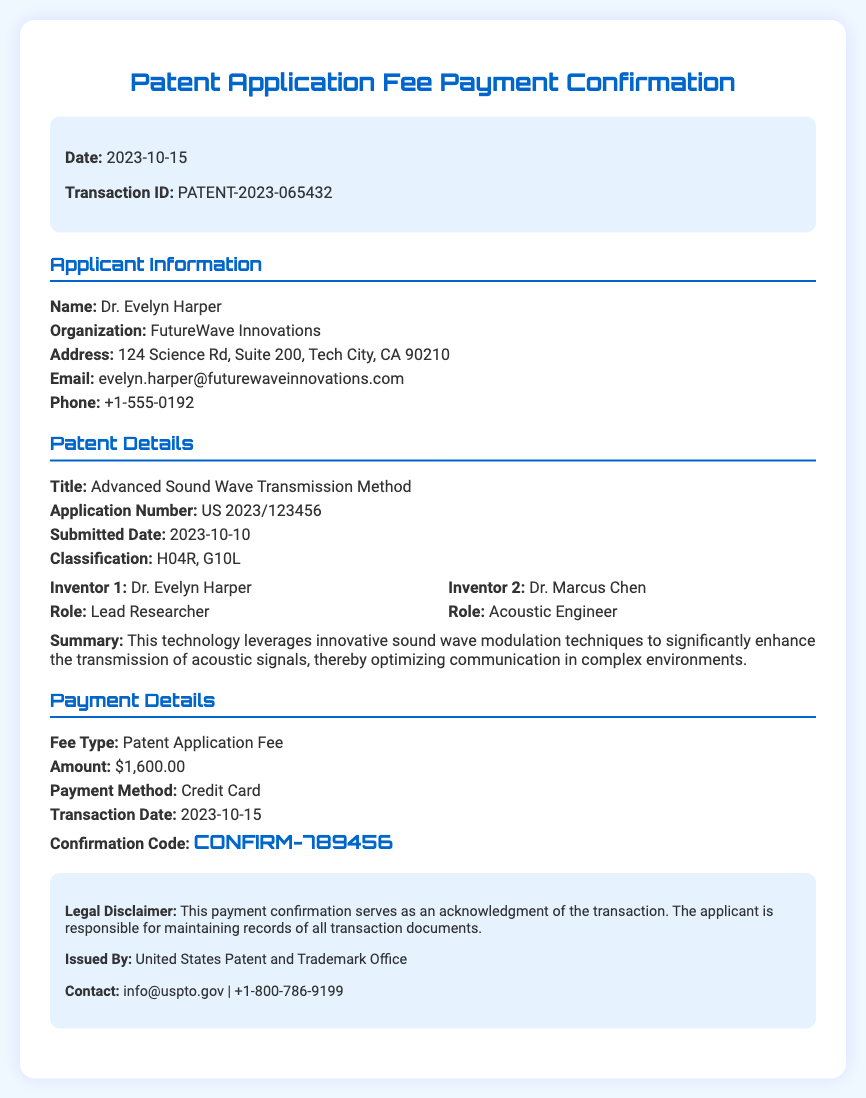What is the date of the confirmation? The date is listed at the top of the document under the header section.
Answer: 2023-10-15 Who is the lead researcher? The document specifies the role of Dr. Evelyn Harper as the lead researcher in the patent details section.
Answer: Dr. Evelyn Harper What is the application number? The application number is provided in the patent details section, which is a specific identifier for the patent application.
Answer: US 2023/123456 What is the confirmation code? The confirmation code is highlighted in the payment details section as an important identification for the transaction.
Answer: CONFIRM-789456 How much is the patent application fee? The amount is clearly stated in the payment details section of the document.
Answer: $1,600.00 What organization is Dr. Evelyn Harper affiliated with? The document lists the organization in the applicant information section, which identifies the institution associated with the applicant.
Answer: FutureWave Innovations What is the title of the patent? The title is stated in the patent details section to describe the focus of the application.
Answer: Advanced Sound Wave Transmission Method When was the application submitted? The submission date is provided in the patent details section, indicating when the application was officially filed.
Answer: 2023-10-10 Which payment method was used? The payment method is mentioned in the payment details section, indicating how the fee was paid.
Answer: Credit Card 